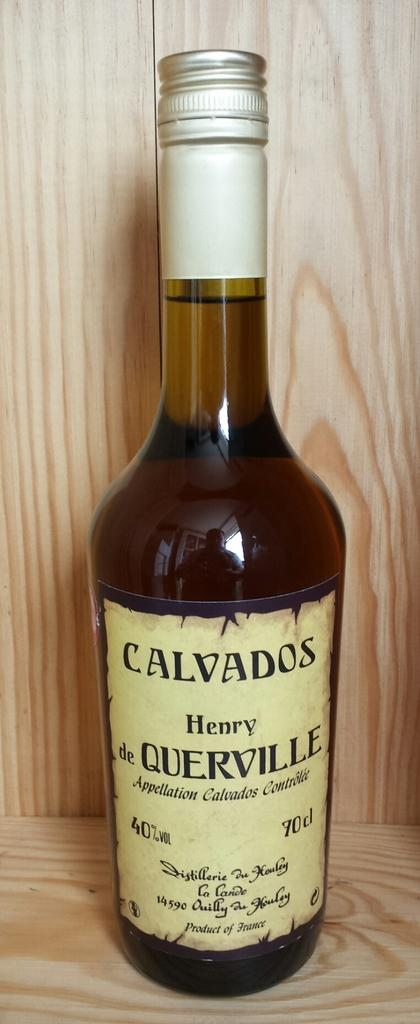What object is on the table in the image? There is a bottle on the table in the image. What can be found on the surface of the bottle? The bottle has a label. What type of dress is the bottle wearing in the image? There is no dress present in the image, as the bottle is an inanimate object and does not wear clothing. 